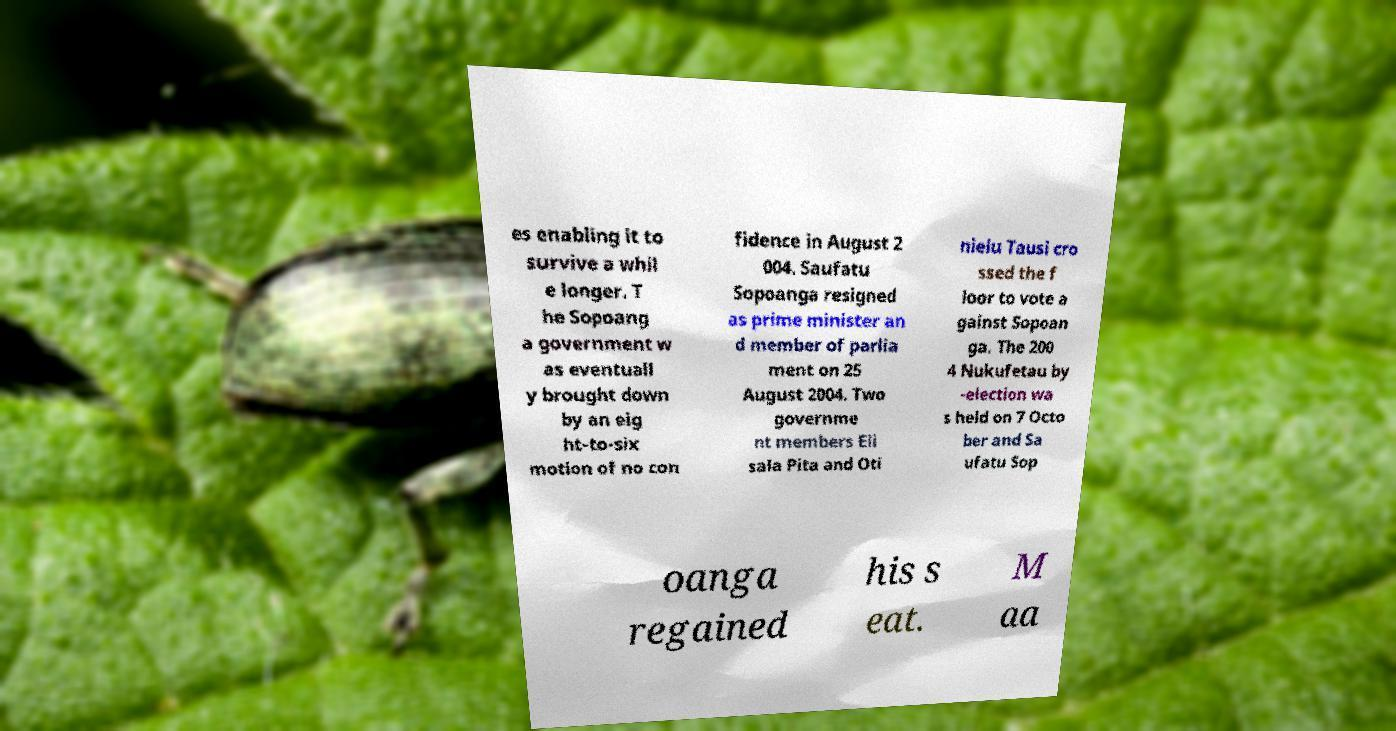For documentation purposes, I need the text within this image transcribed. Could you provide that? es enabling it to survive a whil e longer. T he Sopoang a government w as eventuall y brought down by an eig ht-to-six motion of no con fidence in August 2 004. Saufatu Sopoanga resigned as prime minister an d member of parlia ment on 25 August 2004. Two governme nt members Eli sala Pita and Oti nielu Tausi cro ssed the f loor to vote a gainst Sopoan ga. The 200 4 Nukufetau by -election wa s held on 7 Octo ber and Sa ufatu Sop oanga regained his s eat. M aa 